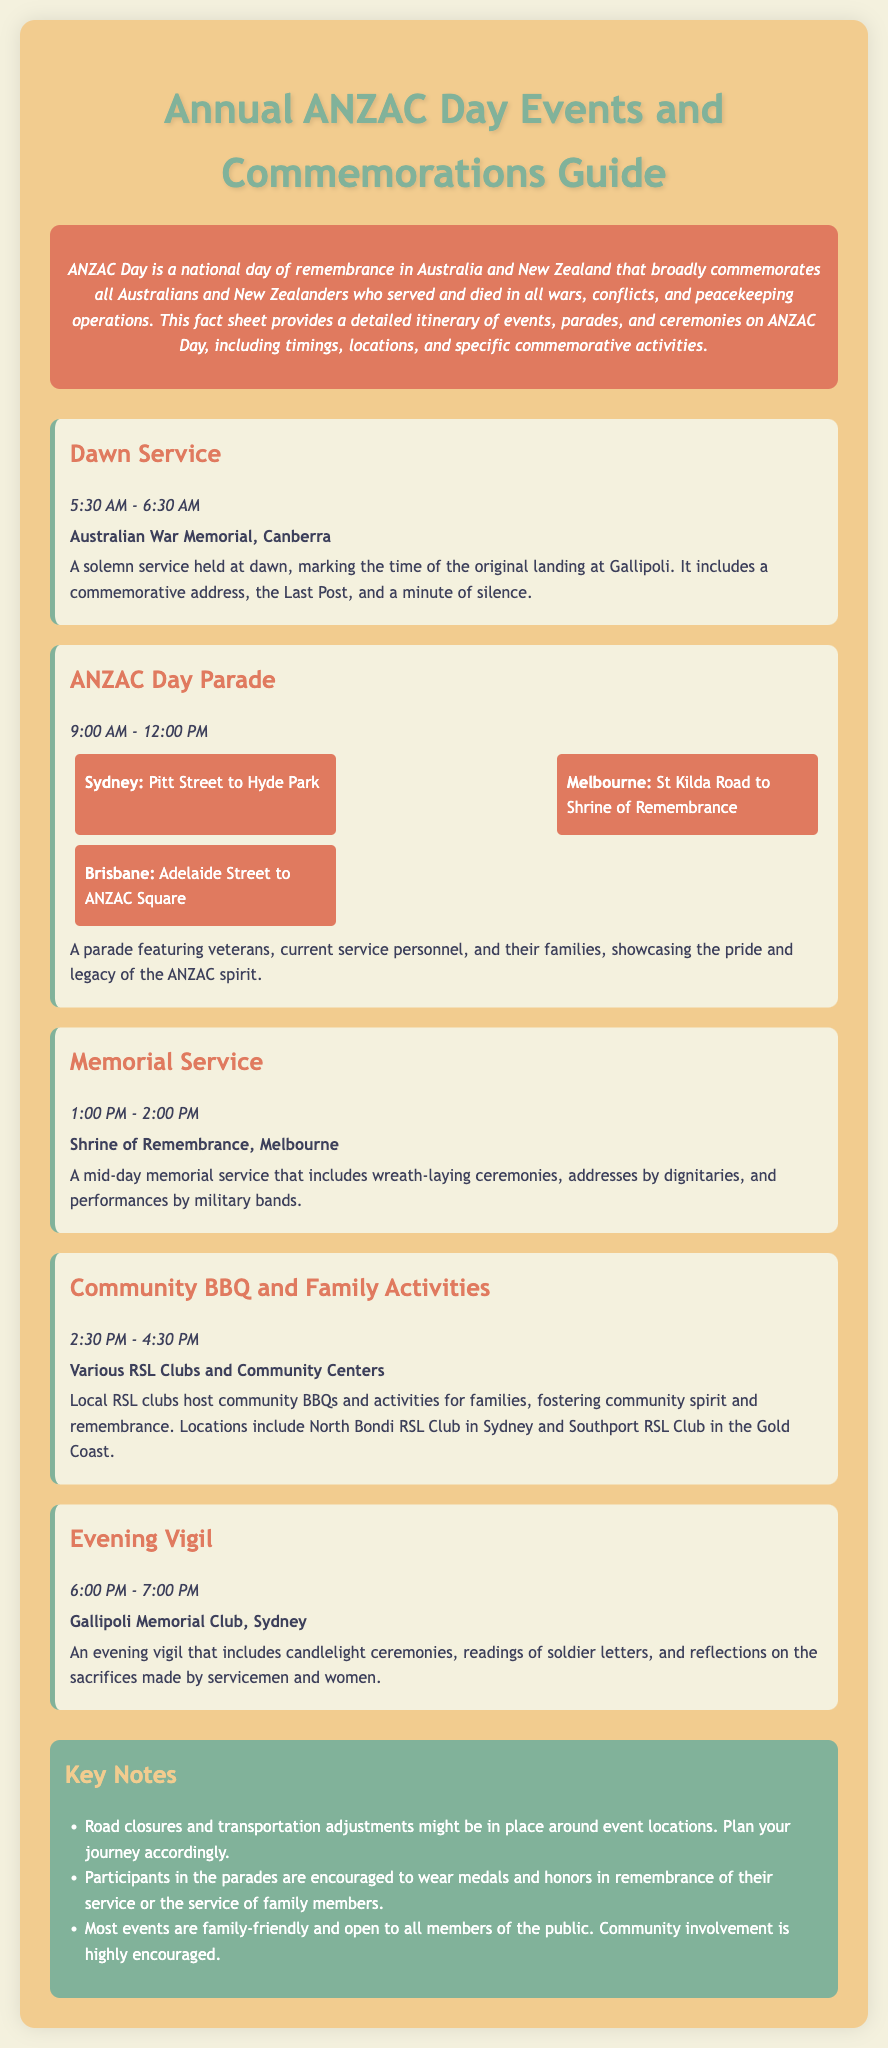What time does the Dawn Service start? The start time for the Dawn Service is stated in the document as 5:30 AM.
Answer: 5:30 AM Where is the ANZAC Day Parade held in Melbourne? The document specifies the location of the ANZAC Day Parade in Melbourne as St Kilda Road to Shrine of Remembrance.
Answer: St Kilda Road to Shrine of Remembrance What event takes place after the Memorial Service? The document lists the Community BBQ and Family Activities as the event that follows the Memorial Service.
Answer: Community BBQ and Family Activities How long is the Evening Vigil? The document states that the Evening Vigil lasts for one hour, from 6:00 PM to 7:00 PM.
Answer: 1 hour What is the main purpose of ANZAC Day? The document describes ANZAC Day as a national day of remembrance for those who served and died.
Answer: Remembrance Which location hosts the Dawn Service? Australia's capital hosts the Dawn Service at the Australian War Memorial, as noted in the document.
Answer: Australian War Memorial, Canberra What suggestions are made regarding participation in the parades? The document advises participants in the parades to wear medals and honors.
Answer: Wear medals and honors How many locations are listed for the ANZAC Day Parade? The document lists a total of three locations for the ANZAC Day Parade: Sydney, Melbourne, and Brisbane.
Answer: Three locations 